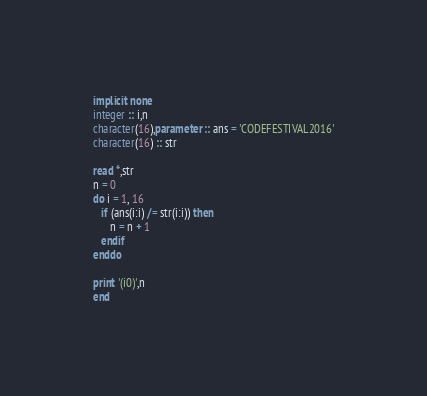Convert code to text. <code><loc_0><loc_0><loc_500><loc_500><_FORTRAN_>implicit none
integer :: i,n
character(16),parameter :: ans = 'CODEFESTIVAL2016'
character(16) :: str

read *,str
n = 0
do i = 1, 16
   if (ans(i:i) /= str(i:i)) then
      n = n + 1
   endif
enddo

print '(i0)',n
end</code> 